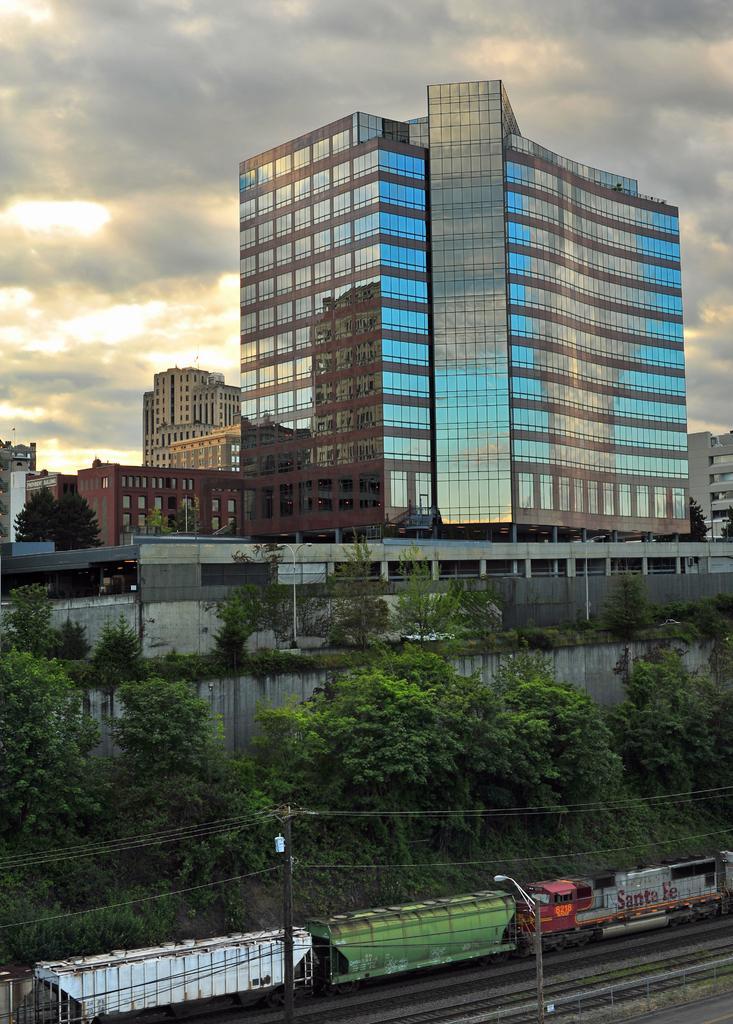Could you give a brief overview of what you see in this image? In this image I can see the train on the track. The train is in white, green and red color. To the side of the train there are many trees. In the back I can see many buildings, clouds and the sky. 